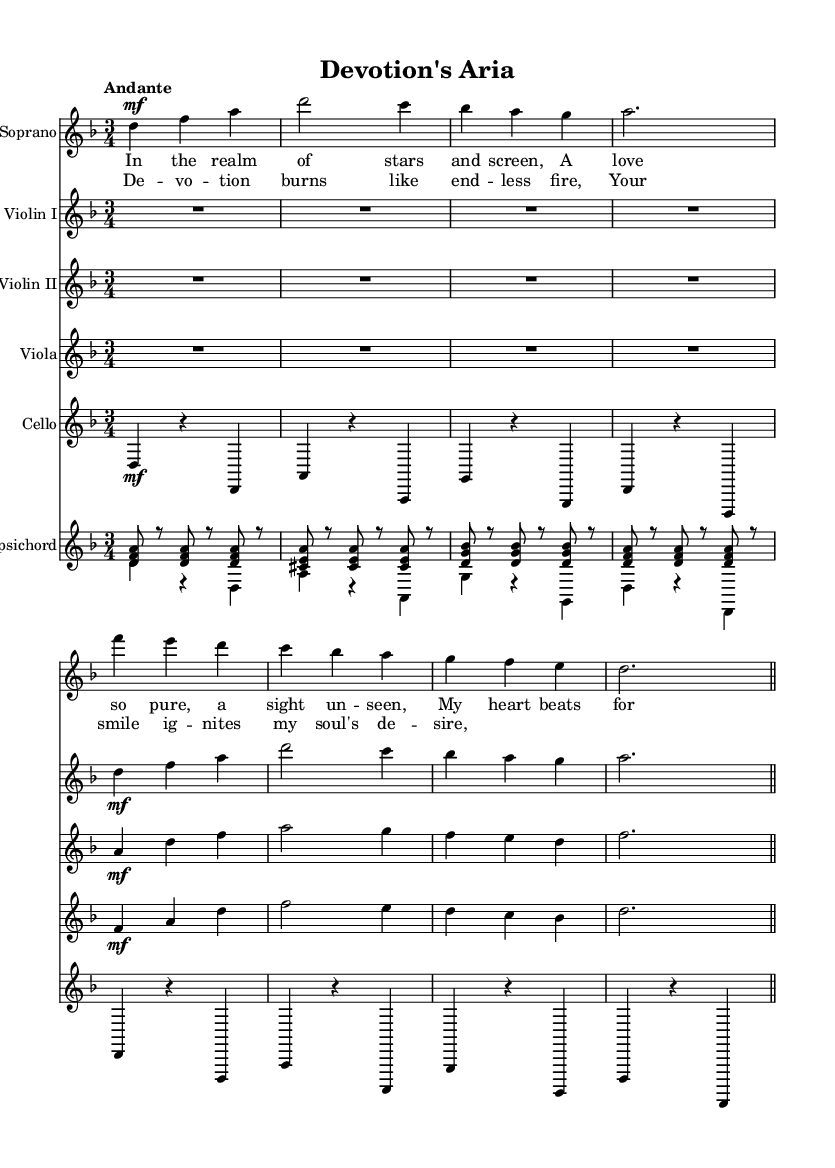What is the key signature of this music? The key signature is indicated at the beginning of the music sheet. It shows one flat, which corresponds to the key of D minor.
Answer: D minor What is the time signature of this music? The time signature is found at the beginning of the sheet music, where it is noted as three beats per measure, specifically indicated as 3/4.
Answer: 3/4 What is the tempo marking of this piece? The tempo marking is indicated above the staff as "Andante," which suggests a moderate pace.
Answer: Andante How many measures does the provided music occupy? By examining the staff and counting the bar lines, we identify the number of measures. The music contains 8 measures in total.
Answer: 8 What is the highest note in the soprano part? The highest note can be identified by looking at the soprano part and finding the highest pitch, which occurs at f.
Answer: f What is the function of the harpsichord in this piece? The harpsichord typically provides harmonic support and can also serve as a continuo instrument, enhancing the texture of the piece. In this music, it complements melodic lines.
Answer: Harmonic support What themes does the lyric in the verse express? The lyrics express themes of love and devotion, focusing on feelings towards a beloved figure, which parallels Tollywood romance plots.
Answer: Love and devotion 